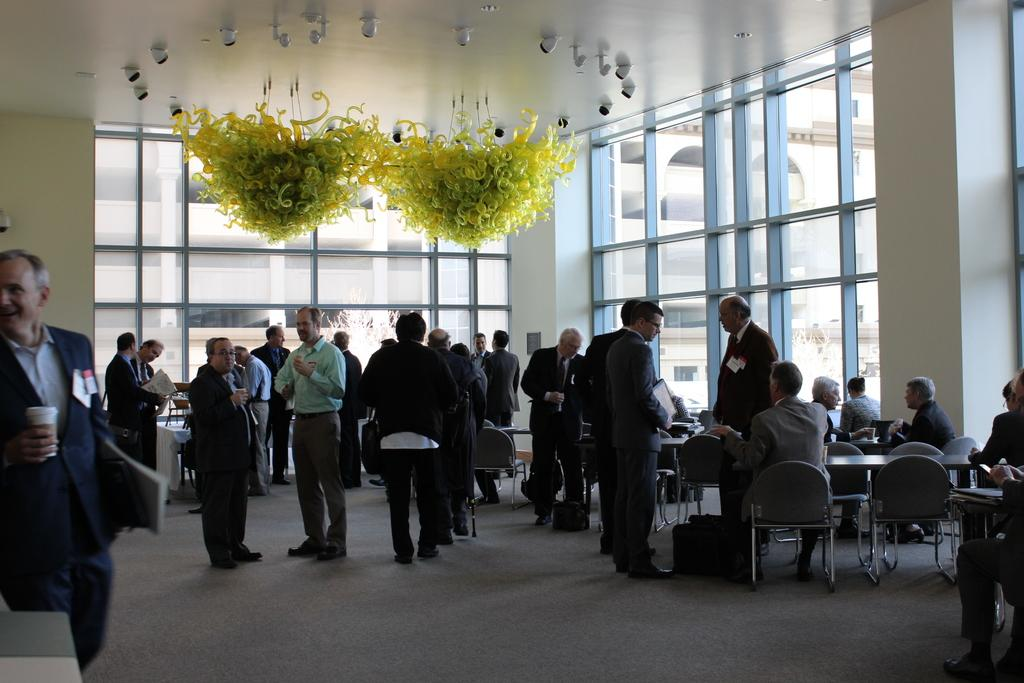What is the general activity of the people in the room? There are many people standing and sitting in the room. Can you describe the lighting in the room? There is a yellow color chandelier hanging from the ceiling. How many chickens are present in the room? There are no chickens present in the room; the image features people standing and sitting. What type of hat is being worn by the person sitting in the front row? There is no hat visible in the image; the focus is on the people and the chandelier. 